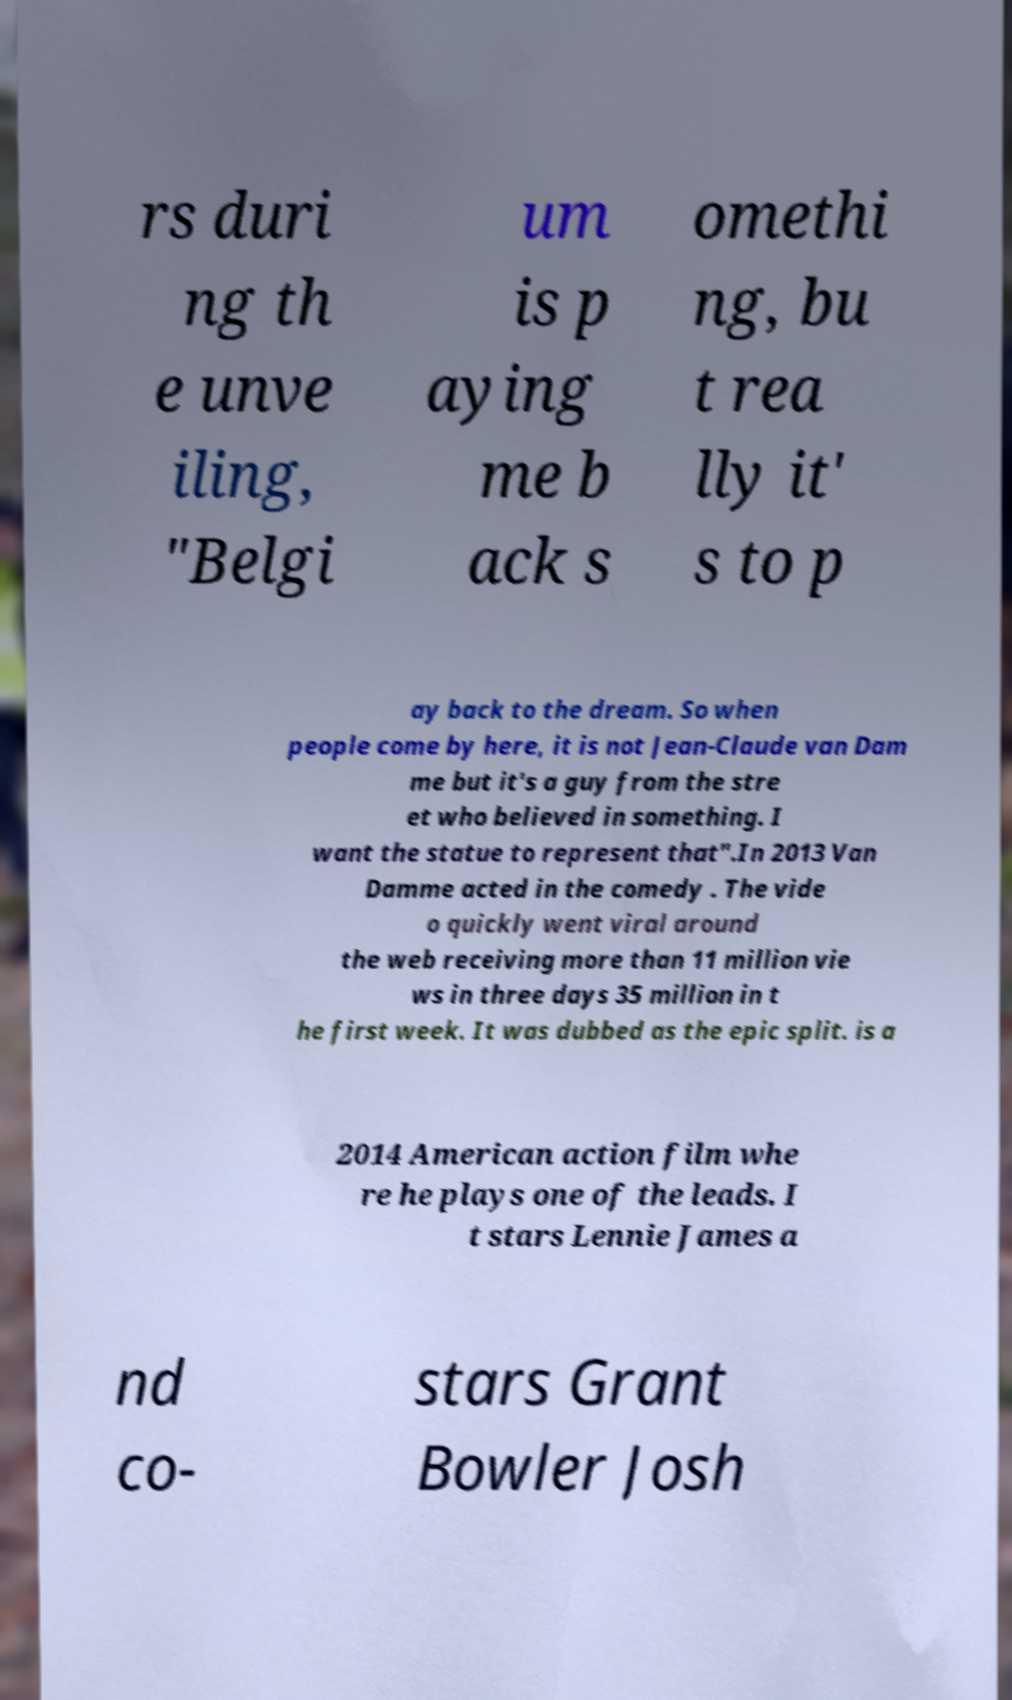I need the written content from this picture converted into text. Can you do that? rs duri ng th e unve iling, "Belgi um is p aying me b ack s omethi ng, bu t rea lly it' s to p ay back to the dream. So when people come by here, it is not Jean-Claude van Dam me but it's a guy from the stre et who believed in something. I want the statue to represent that".In 2013 Van Damme acted in the comedy . The vide o quickly went viral around the web receiving more than 11 million vie ws in three days 35 million in t he first week. It was dubbed as the epic split. is a 2014 American action film whe re he plays one of the leads. I t stars Lennie James a nd co- stars Grant Bowler Josh 